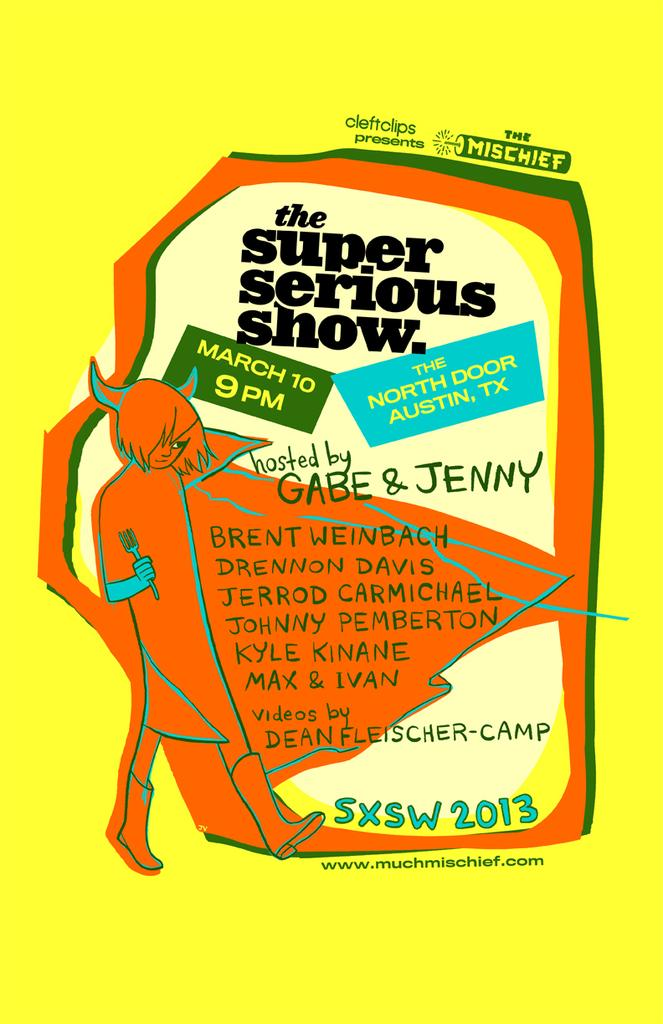<image>
Describe the image concisely. A poster showing a show on March 10 at 9 PM. 